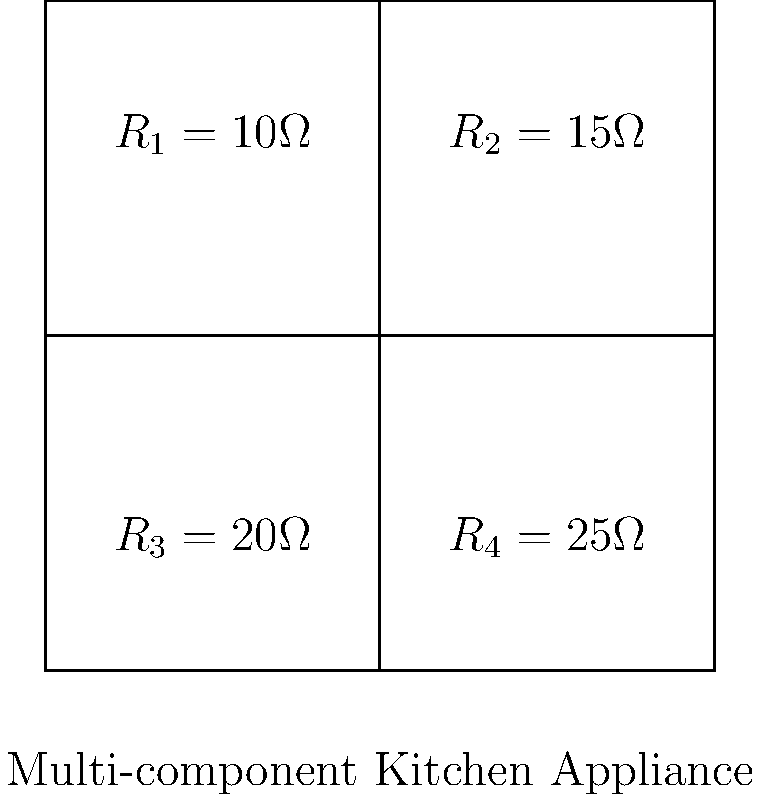A high-end kitchen appliance consists of four heating elements connected in series. The resistances of these elements are $R_1 = 10\Omega$, $R_2 = 15\Omega$, $R_3 = 20\Omega$, and $R_4 = 25\Omega$. Calculate the total resistance of this appliance. To find the total resistance of a series circuit, we add the individual resistances:

1. Identify the resistances:
   $R_1 = 10\Omega$
   $R_2 = 15\Omega$
   $R_3 = 20\Omega$
   $R_4 = 25\Omega$

2. Use the formula for total resistance in series:
   $R_{total} = R_1 + R_2 + R_3 + R_4$

3. Substitute the values:
   $R_{total} = 10\Omega + 15\Omega + 20\Omega + 25\Omega$

4. Calculate the sum:
   $R_{total} = 70\Omega$

Therefore, the total resistance of the kitchen appliance is 70Ω.
Answer: $70\Omega$ 